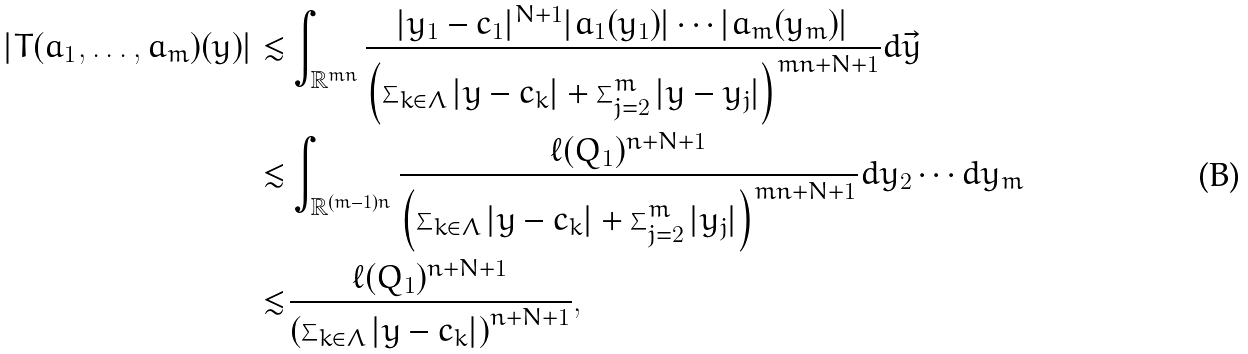Convert formula to latex. <formula><loc_0><loc_0><loc_500><loc_500>| T ( a _ { 1 } , \dots , a _ { m } ) ( y ) | \lesssim & \int _ { \mathbb { R } ^ { m n } } \frac { | y _ { 1 } - c _ { 1 } | ^ { N + 1 } | a _ { 1 } ( y _ { 1 } ) | \cdots | a _ { m } ( y _ { m } ) | } { \left ( \sum _ { k \in \Lambda } | y - c _ { k } | + \sum _ { j = 2 } ^ { m } | y - y _ { j } | \right ) ^ { m n + N + 1 } } d \vec { y } \\ \lesssim & \int _ { \mathbb { R } ^ { ( m - 1 ) n } } \frac { \ell ( Q _ { 1 } ) ^ { n + N + 1 } } { \left ( \sum _ { k \in \Lambda } | y - c _ { k } | + \sum _ { j = 2 } ^ { m } | y _ { j } | \right ) ^ { m n + N + 1 } } d y _ { 2 } \cdots d y _ { m } \\ \lesssim & \frac { \ell ( Q _ { 1 } ) ^ { n + N + 1 } } { \left ( \sum _ { k \in \Lambda } | y - c _ { k } | \right ) ^ { n + N + 1 } } ,</formula> 